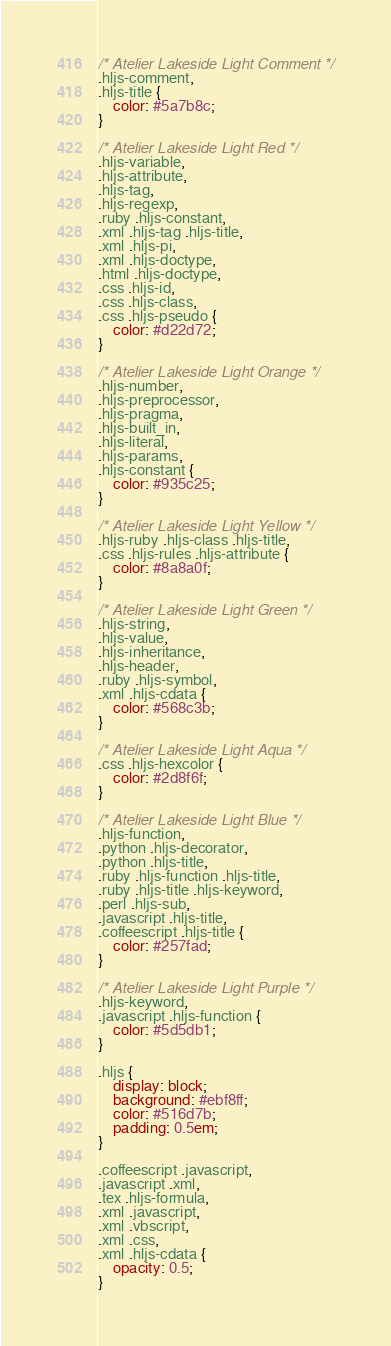Convert code to text. <code><loc_0><loc_0><loc_500><loc_500><_CSS_>
/* Atelier Lakeside Light Comment */
.hljs-comment,
.hljs-title {
	color: #5a7b8c;
}

/* Atelier Lakeside Light Red */
.hljs-variable,
.hljs-attribute,
.hljs-tag,
.hljs-regexp,
.ruby .hljs-constant,
.xml .hljs-tag .hljs-title,
.xml .hljs-pi,
.xml .hljs-doctype,
.html .hljs-doctype,
.css .hljs-id,
.css .hljs-class,
.css .hljs-pseudo {
	color: #d22d72;
}

/* Atelier Lakeside Light Orange */
.hljs-number,
.hljs-preprocessor,
.hljs-pragma,
.hljs-built_in,
.hljs-literal,
.hljs-params,
.hljs-constant {
	color: #935c25;
}

/* Atelier Lakeside Light Yellow */
.hljs-ruby .hljs-class .hljs-title,
.css .hljs-rules .hljs-attribute {
	color: #8a8a0f;
}

/* Atelier Lakeside Light Green */
.hljs-string,
.hljs-value,
.hljs-inheritance,
.hljs-header,
.ruby .hljs-symbol,
.xml .hljs-cdata {
	color: #568c3b;
}

/* Atelier Lakeside Light Aqua */
.css .hljs-hexcolor {
	color: #2d8f6f;
}

/* Atelier Lakeside Light Blue */
.hljs-function,
.python .hljs-decorator,
.python .hljs-title,
.ruby .hljs-function .hljs-title,
.ruby .hljs-title .hljs-keyword,
.perl .hljs-sub,
.javascript .hljs-title,
.coffeescript .hljs-title {
	color: #257fad;
}

/* Atelier Lakeside Light Purple */
.hljs-keyword,
.javascript .hljs-function {
	color: #5d5db1;
}

.hljs {
	display: block;
	background: #ebf8ff;
	color: #516d7b;
	padding: 0.5em;
}

.coffeescript .javascript,
.javascript .xml,
.tex .hljs-formula,
.xml .javascript,
.xml .vbscript,
.xml .css,
.xml .hljs-cdata {
	opacity: 0.5;
}
</code> 